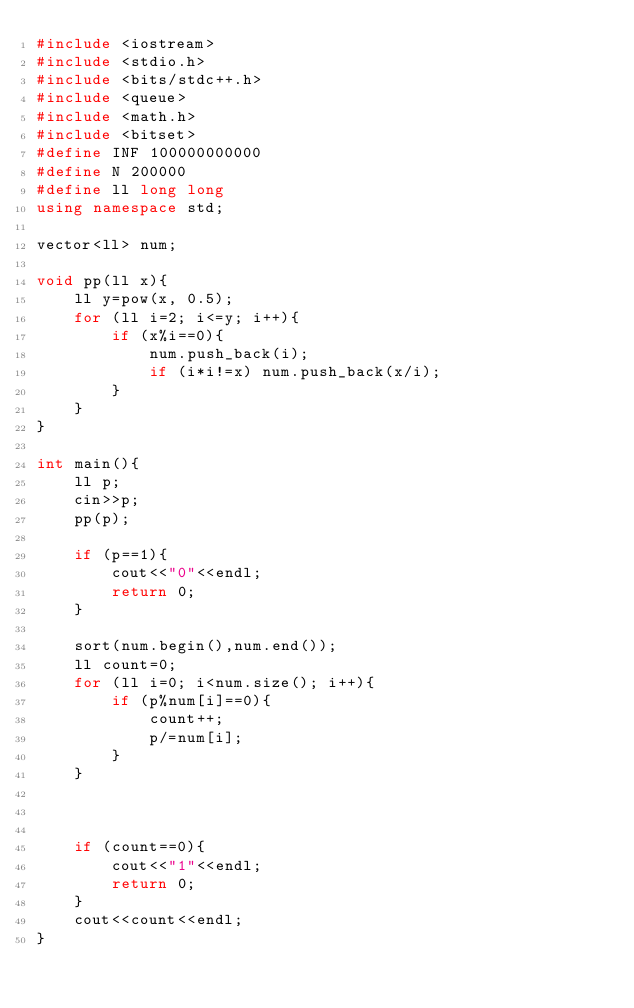<code> <loc_0><loc_0><loc_500><loc_500><_C++_>#include <iostream>
#include <stdio.h>
#include <bits/stdc++.h>
#include <queue>
#include <math.h>
#include <bitset>
#define INF 100000000000
#define N 200000
#define ll long long
using namespace std;

vector<ll> num;

void pp(ll x){
    ll y=pow(x, 0.5);
    for (ll i=2; i<=y; i++){
        if (x%i==0){
            num.push_back(i);
            if (i*i!=x) num.push_back(x/i);
        }
    }
}

int main(){
    ll p;
    cin>>p;
    pp(p);
    
    if (p==1){
        cout<<"0"<<endl;
        return 0;
    }
    
    sort(num.begin(),num.end());
    ll count=0;
    for (ll i=0; i<num.size(); i++){
        if (p%num[i]==0){
            count++;
            p/=num[i];
        }
    }
    
    
    
    if (count==0){
        cout<<"1"<<endl;
        return 0;
    }
    cout<<count<<endl;
}</code> 